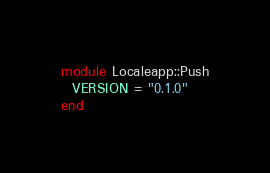<code> <loc_0><loc_0><loc_500><loc_500><_Crystal_>module Localeapp::Push
  VERSION = "0.1.0"
end
</code> 